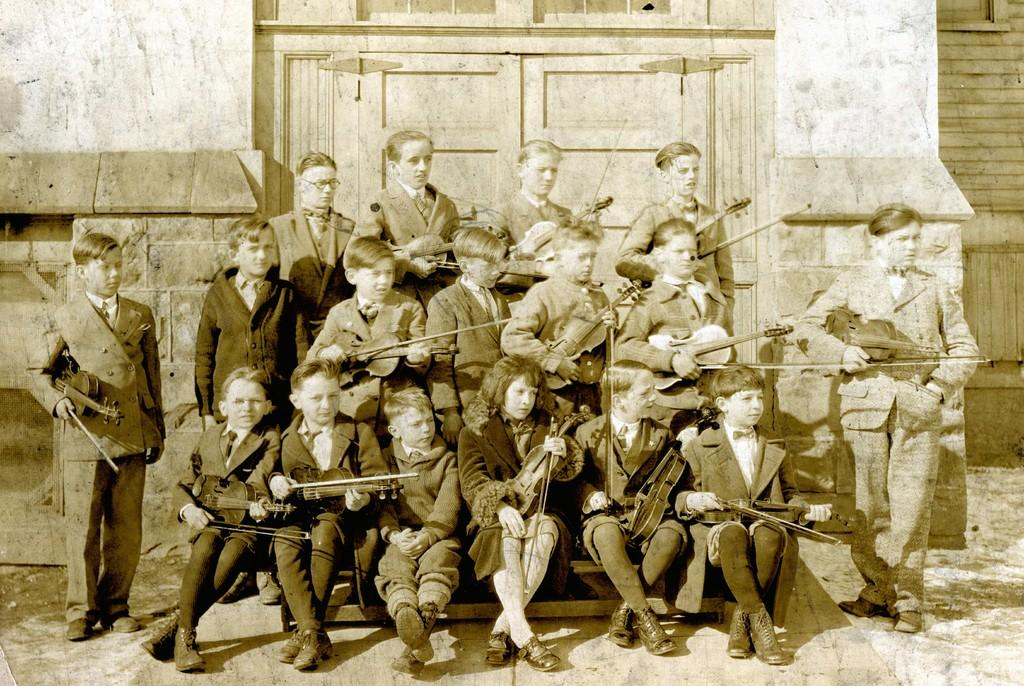What is the main subject of the image? The main subject of the image is a group of people. What are the people in the image doing? The people are holding musical instruments. What architectural features can be seen in the image? There is a door and a wall visible in the image. Where is the faucet located in the image? There is no faucet present in the image. What need do the people in the image have for the musical instruments? The image does not provide information about the people's need for the musical instruments; it only shows them holding the instruments. 